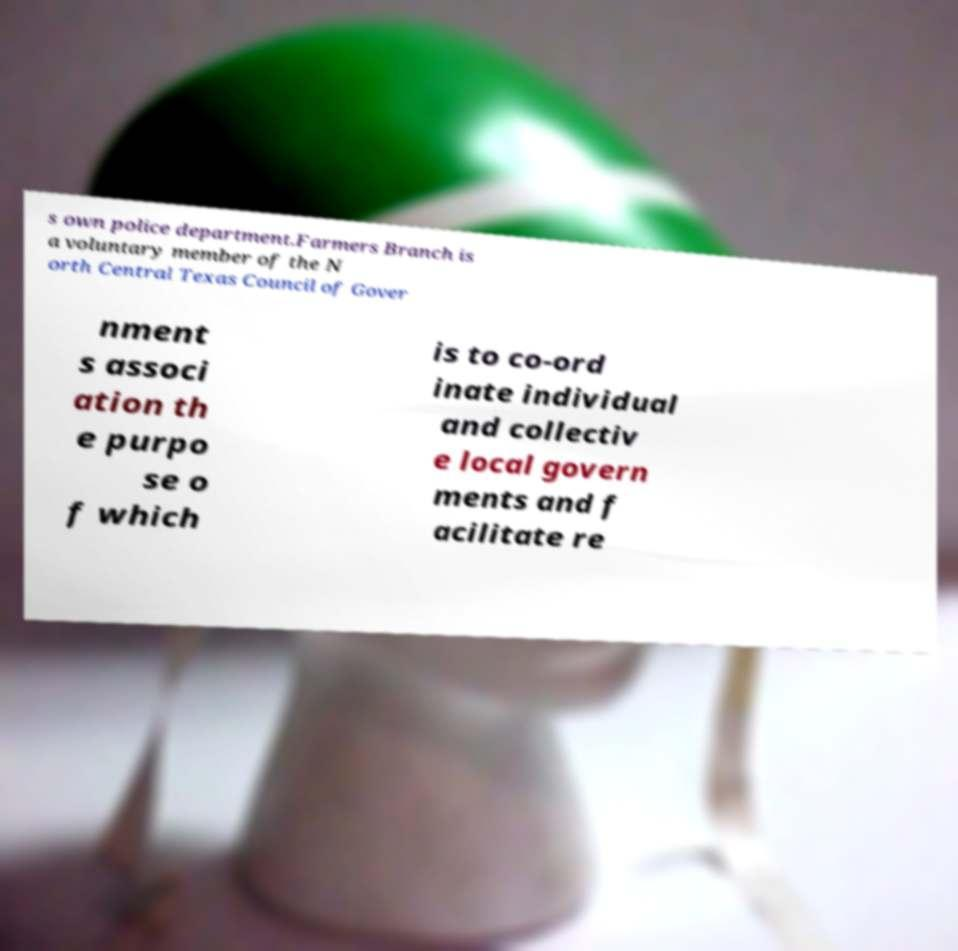Please identify and transcribe the text found in this image. s own police department.Farmers Branch is a voluntary member of the N orth Central Texas Council of Gover nment s associ ation th e purpo se o f which is to co-ord inate individual and collectiv e local govern ments and f acilitate re 